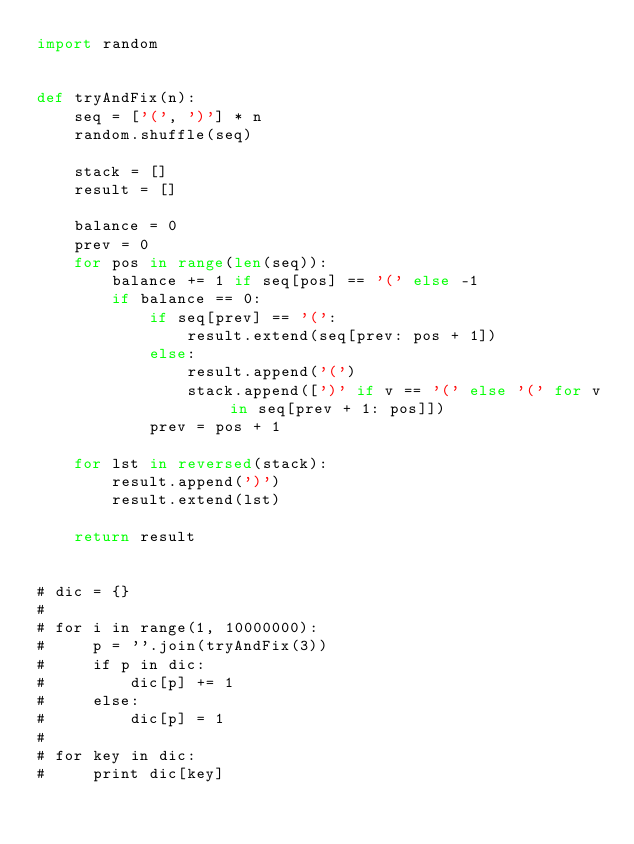<code> <loc_0><loc_0><loc_500><loc_500><_Python_>import random


def tryAndFix(n):
    seq = ['(', ')'] * n
    random.shuffle(seq)

    stack = []
    result = []

    balance = 0
    prev = 0
    for pos in range(len(seq)):
        balance += 1 if seq[pos] == '(' else -1
        if balance == 0:
            if seq[prev] == '(':
                result.extend(seq[prev: pos + 1])
            else:
                result.append('(')
                stack.append([')' if v == '(' else '(' for v in seq[prev + 1: pos]])
            prev = pos + 1

    for lst in reversed(stack):
        result.append(')')
        result.extend(lst)

    return result


# dic = {}
#
# for i in range(1, 10000000):
#     p = ''.join(tryAndFix(3))
#     if p in dic:
#         dic[p] += 1
#     else:
#         dic[p] = 1
#
# for key in dic:
#     print dic[key]
</code> 